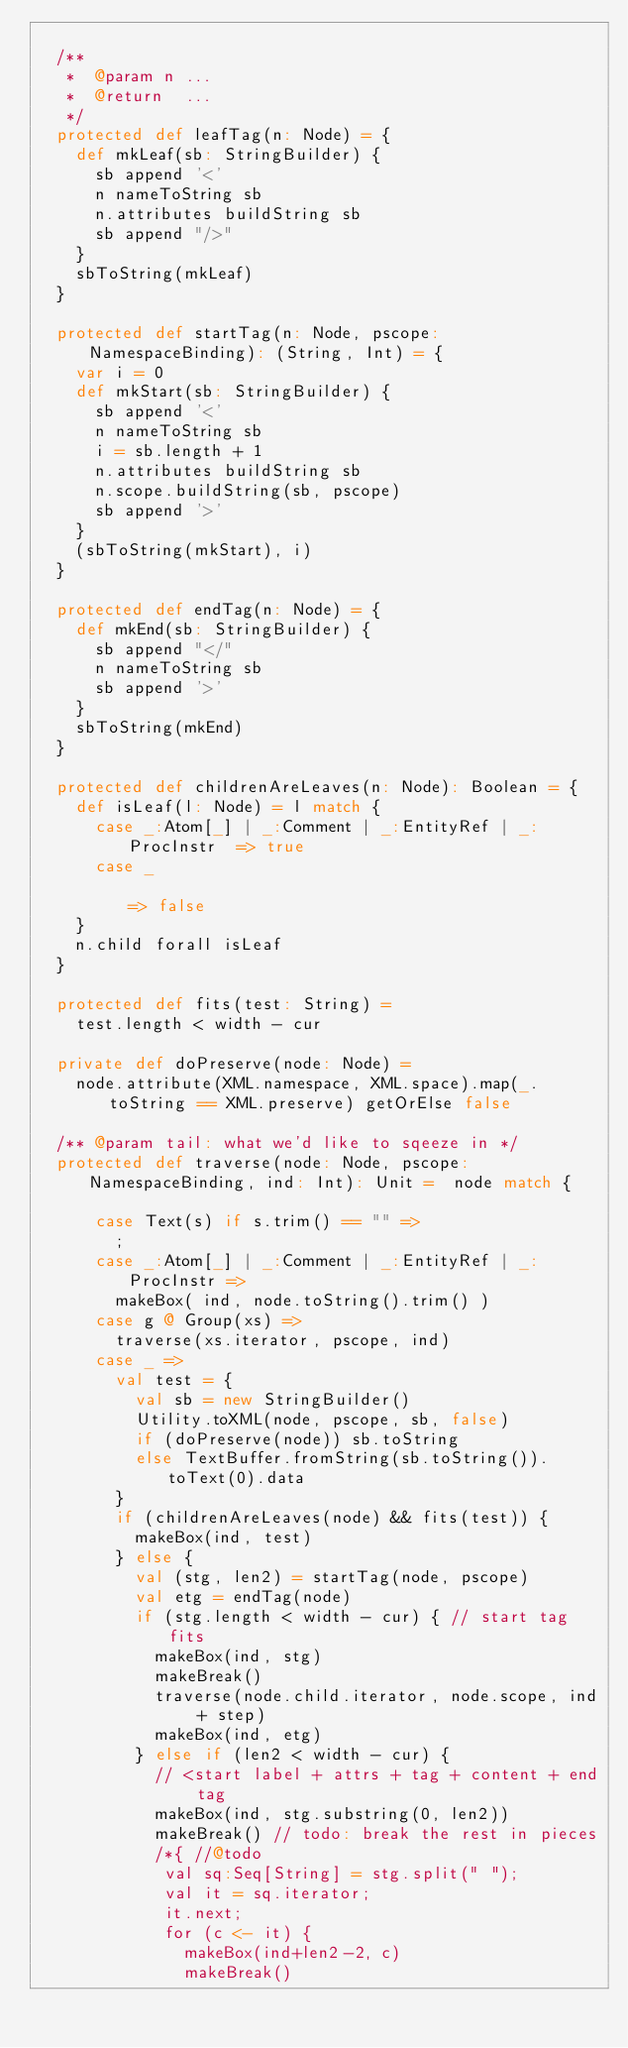<code> <loc_0><loc_0><loc_500><loc_500><_Scala_>
  /**
   *  @param n ...
   *  @return  ...
   */
  protected def leafTag(n: Node) = {
    def mkLeaf(sb: StringBuilder) {
      sb append '<'
      n nameToString sb
      n.attributes buildString sb
      sb append "/>"
    }
    sbToString(mkLeaf)
  }

  protected def startTag(n: Node, pscope: NamespaceBinding): (String, Int) = {
    var i = 0
    def mkStart(sb: StringBuilder) {
      sb append '<'
      n nameToString sb
      i = sb.length + 1
      n.attributes buildString sb
      n.scope.buildString(sb, pscope)
      sb append '>'
    }
    (sbToString(mkStart), i)
  }

  protected def endTag(n: Node) = {  
    def mkEnd(sb: StringBuilder) {
      sb append "</"
      n nameToString sb
      sb append '>'
    }
    sbToString(mkEnd)
  }

  protected def childrenAreLeaves(n: Node): Boolean = {
    def isLeaf(l: Node) = l match {
      case _:Atom[_] | _:Comment | _:EntityRef | _:ProcInstr  => true
      case _                                                  => false
    }
    n.child forall isLeaf
  }

  protected def fits(test: String) =
    test.length < width - cur

  private def doPreserve(node: Node) =
    node.attribute(XML.namespace, XML.space).map(_.toString == XML.preserve) getOrElse false
      
  /** @param tail: what we'd like to sqeeze in */
  protected def traverse(node: Node, pscope: NamespaceBinding, ind: Int): Unit =  node match {

      case Text(s) if s.trim() == "" =>
        ;
      case _:Atom[_] | _:Comment | _:EntityRef | _:ProcInstr => 
        makeBox( ind, node.toString().trim() )
      case g @ Group(xs) =>
        traverse(xs.iterator, pscope, ind)
      case _ =>
        val test = {
          val sb = new StringBuilder()
          Utility.toXML(node, pscope, sb, false)
          if (doPreserve(node)) sb.toString
          else TextBuffer.fromString(sb.toString()).toText(0).data
        }
        if (childrenAreLeaves(node) && fits(test)) {
          makeBox(ind, test)
        } else {
          val (stg, len2) = startTag(node, pscope)
          val etg = endTag(node)
          if (stg.length < width - cur) { // start tag fits
            makeBox(ind, stg)
            makeBreak()
            traverse(node.child.iterator, node.scope, ind + step)
            makeBox(ind, etg)
          } else if (len2 < width - cur) {
            // <start label + attrs + tag + content + end tag
            makeBox(ind, stg.substring(0, len2))
            makeBreak() // todo: break the rest in pieces
            /*{ //@todo
             val sq:Seq[String] = stg.split(" ");
             val it = sq.iterator;
             it.next;
             for (c <- it) {
               makeBox(ind+len2-2, c)
               makeBreak()</code> 